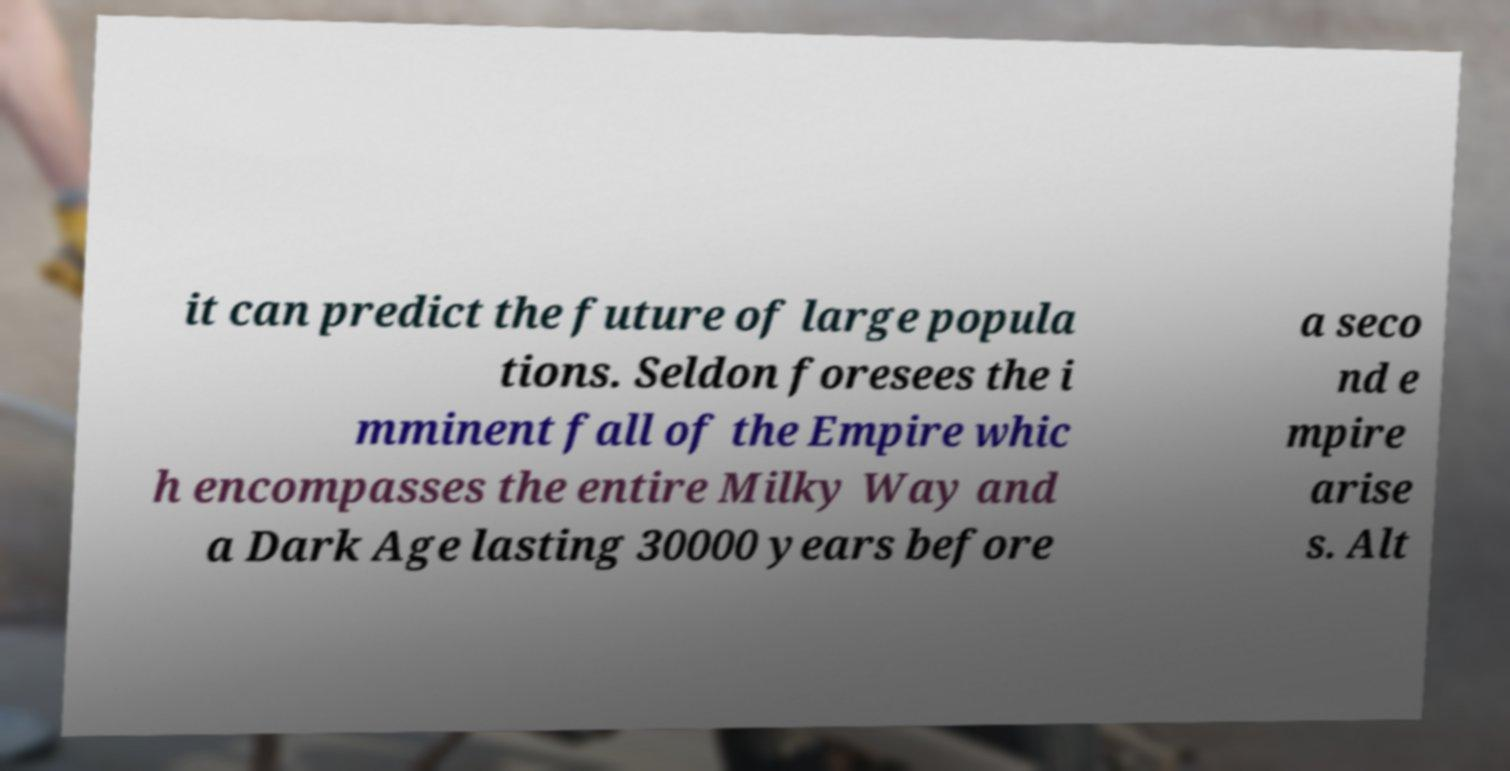Could you assist in decoding the text presented in this image and type it out clearly? it can predict the future of large popula tions. Seldon foresees the i mminent fall of the Empire whic h encompasses the entire Milky Way and a Dark Age lasting 30000 years before a seco nd e mpire arise s. Alt 